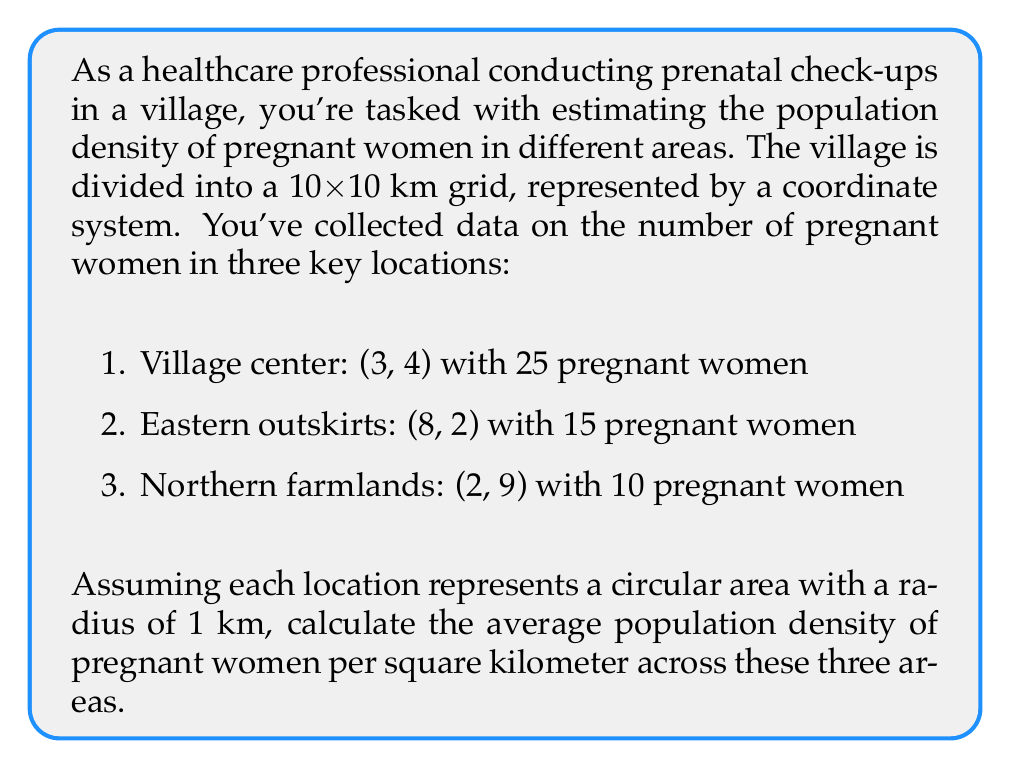Give your solution to this math problem. To solve this problem, we'll follow these steps:

1. Calculate the area of each circular region:
   The area of a circle is given by $A = \pi r^2$
   With a radius of 1 km, the area for each location is:
   $$A = \pi (1)^2 = \pi \approx 3.14159 \text{ km}^2$$

2. Calculate the population density for each location:
   Density = Number of pregnant women / Area

   Village center: $\frac{25}{3.14159} \approx 7.96 \text{ women/km}^2$
   Eastern outskirts: $\frac{15}{3.14159} \approx 4.77 \text{ women/km}^2$
   Northern farmlands: $\frac{10}{3.14159} \approx 3.18 \text{ women/km}^2$

3. Calculate the average density:
   Average density = (Sum of densities) / (Number of locations)
   $$\text{Average density} = \frac{7.96 + 4.77 + 3.18}{3} \approx 5.30 \text{ women/km}^2$$

Therefore, the average population density of pregnant women across these three areas is approximately 5.30 women per square kilometer.
Answer: 5.30 women/km² 